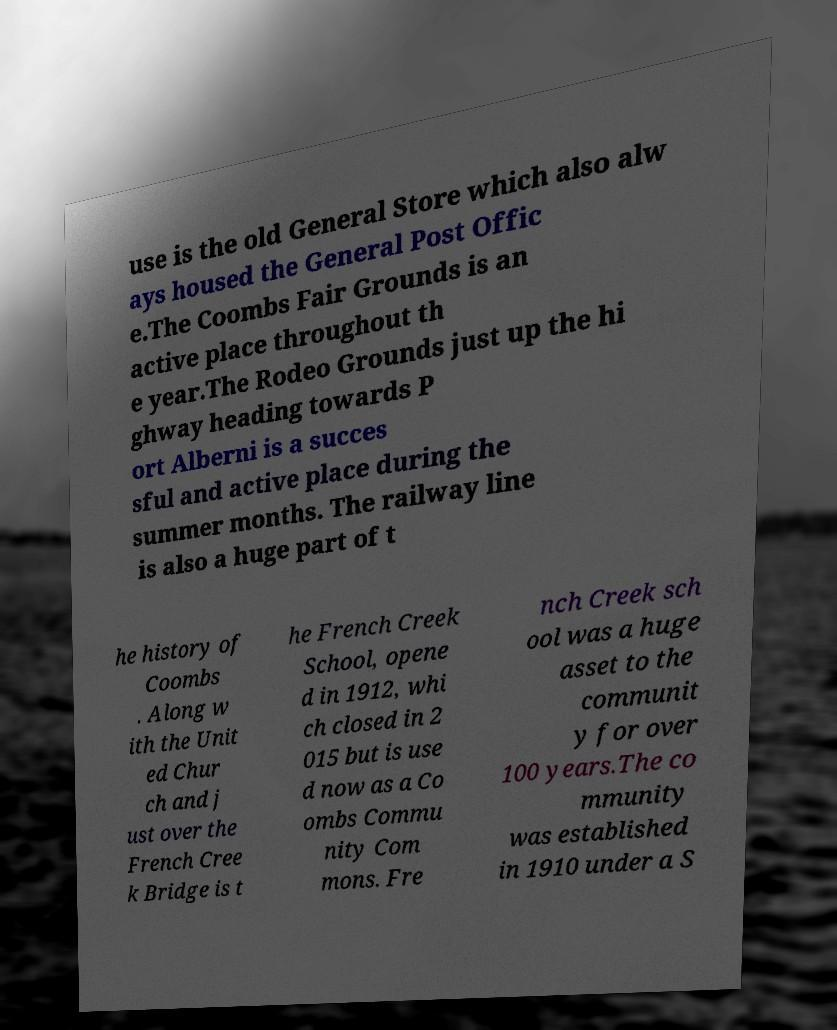What messages or text are displayed in this image? I need them in a readable, typed format. use is the old General Store which also alw ays housed the General Post Offic e.The Coombs Fair Grounds is an active place throughout th e year.The Rodeo Grounds just up the hi ghway heading towards P ort Alberni is a succes sful and active place during the summer months. The railway line is also a huge part of t he history of Coombs . Along w ith the Unit ed Chur ch and j ust over the French Cree k Bridge is t he French Creek School, opene d in 1912, whi ch closed in 2 015 but is use d now as a Co ombs Commu nity Com mons. Fre nch Creek sch ool was a huge asset to the communit y for over 100 years.The co mmunity was established in 1910 under a S 